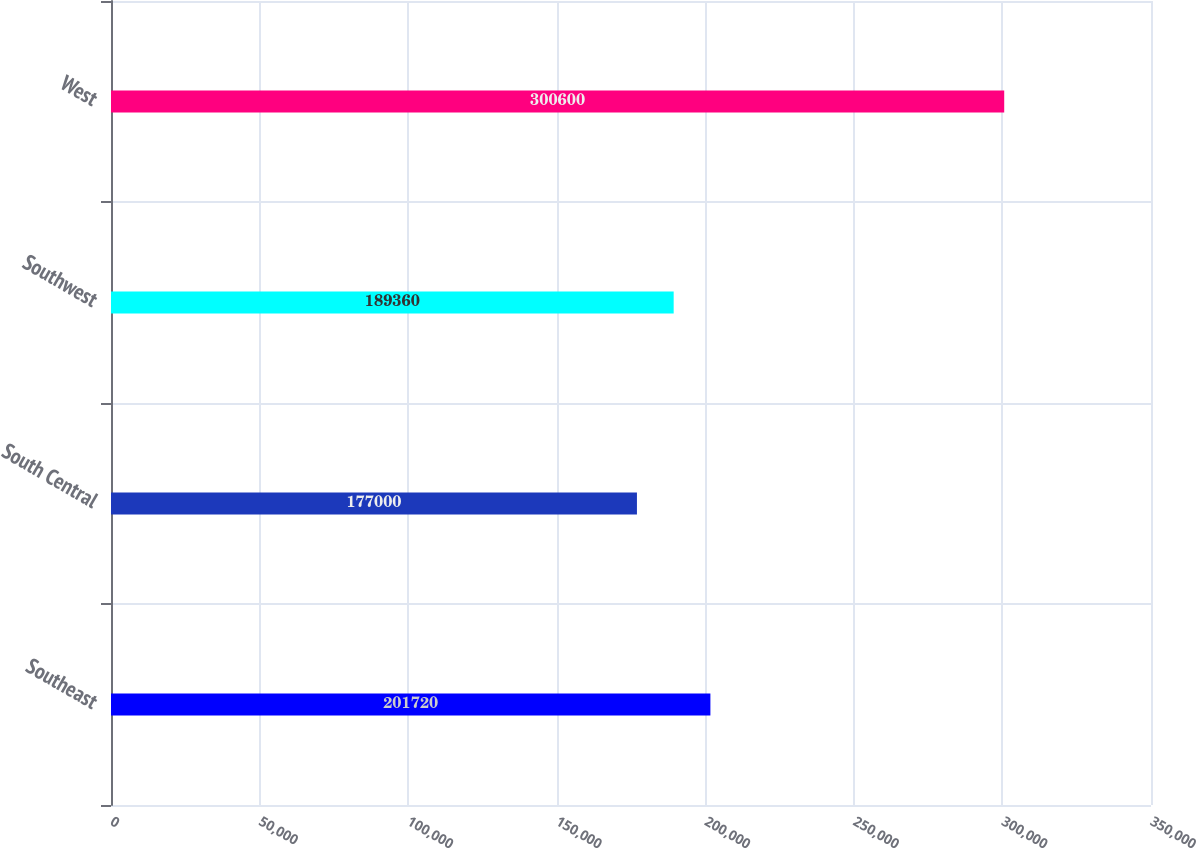<chart> <loc_0><loc_0><loc_500><loc_500><bar_chart><fcel>Southeast<fcel>South Central<fcel>Southwest<fcel>West<nl><fcel>201720<fcel>177000<fcel>189360<fcel>300600<nl></chart> 